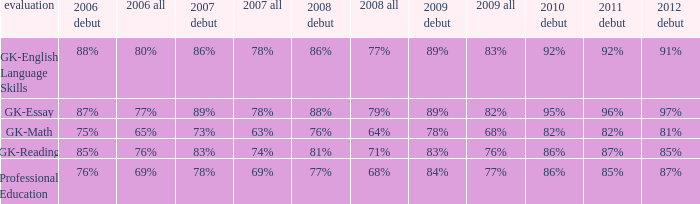When the overall percentage was 82% in 2009, what was the percentage for those experiencing it for the first time in 2012? 97%. 